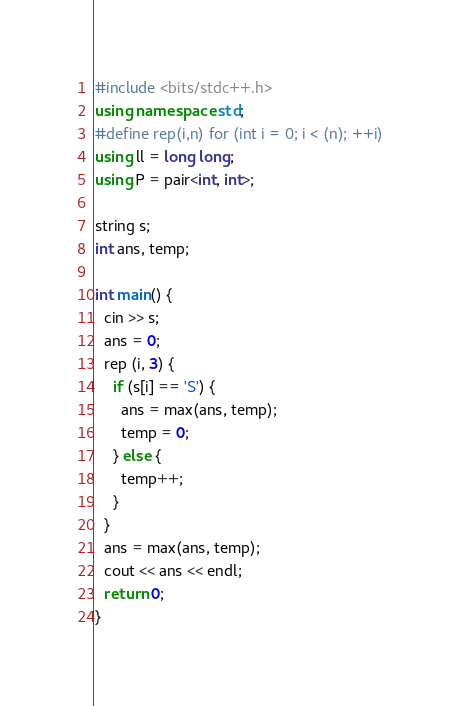<code> <loc_0><loc_0><loc_500><loc_500><_C++_>#include <bits/stdc++.h>
using namespace std;
#define rep(i,n) for (int i = 0; i < (n); ++i)
using ll = long long;
using P = pair<int, int>;

string s;
int ans, temp;

int main() {
  cin >> s;
  ans = 0;
  rep (i, 3) {
    if (s[i] == 'S') {
      ans = max(ans, temp);
      temp = 0;
    } else {
      temp++;
    }
  }
  ans = max(ans, temp);
  cout << ans << endl;
  return 0;
}
</code> 